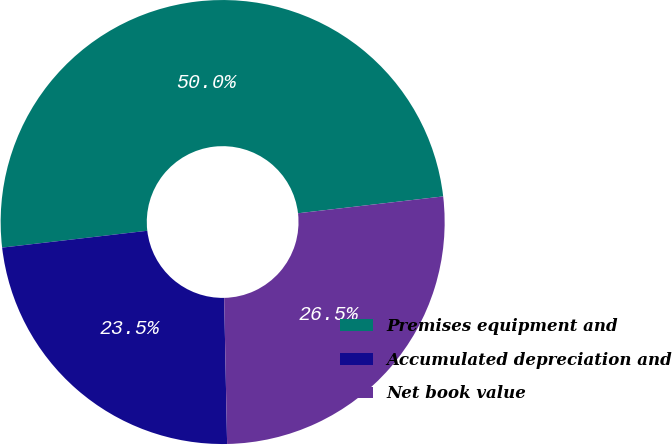Convert chart to OTSL. <chart><loc_0><loc_0><loc_500><loc_500><pie_chart><fcel>Premises equipment and<fcel>Accumulated depreciation and<fcel>Net book value<nl><fcel>50.0%<fcel>23.48%<fcel>26.52%<nl></chart> 